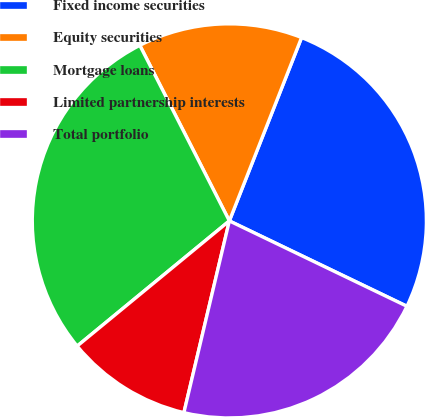Convert chart. <chart><loc_0><loc_0><loc_500><loc_500><pie_chart><fcel>Fixed income securities<fcel>Equity securities<fcel>Mortgage loans<fcel>Limited partnership interests<fcel>Total portfolio<nl><fcel>26.16%<fcel>13.48%<fcel>28.45%<fcel>10.34%<fcel>21.57%<nl></chart> 